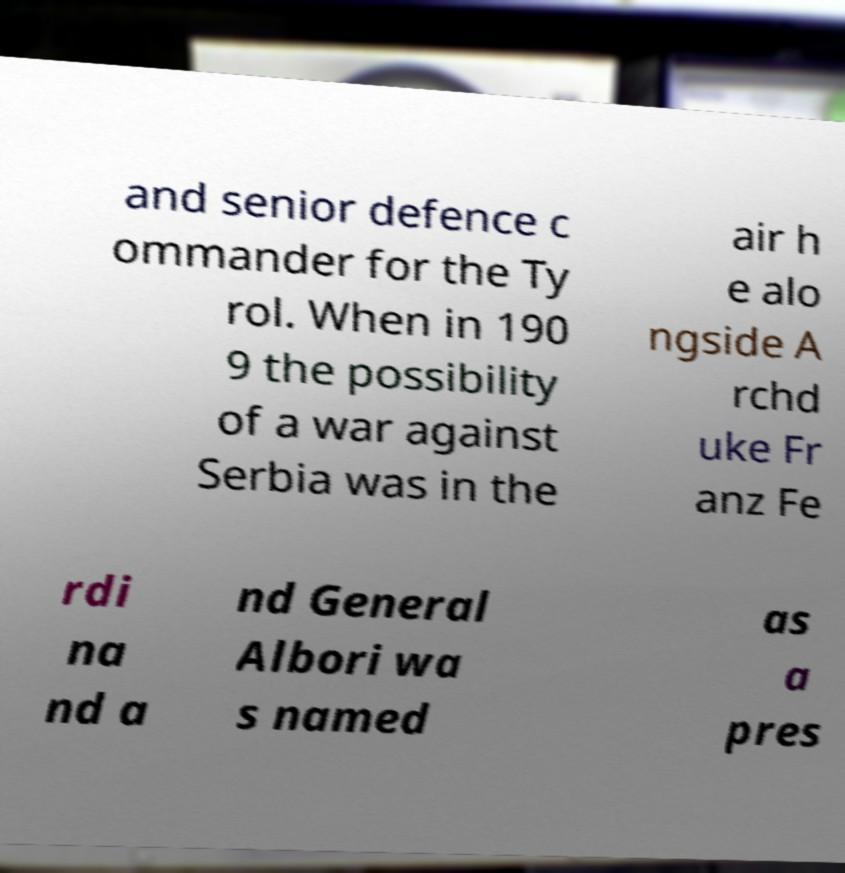Can you accurately transcribe the text from the provided image for me? and senior defence c ommander for the Ty rol. When in 190 9 the possibility of a war against Serbia was in the air h e alo ngside A rchd uke Fr anz Fe rdi na nd a nd General Albori wa s named as a pres 